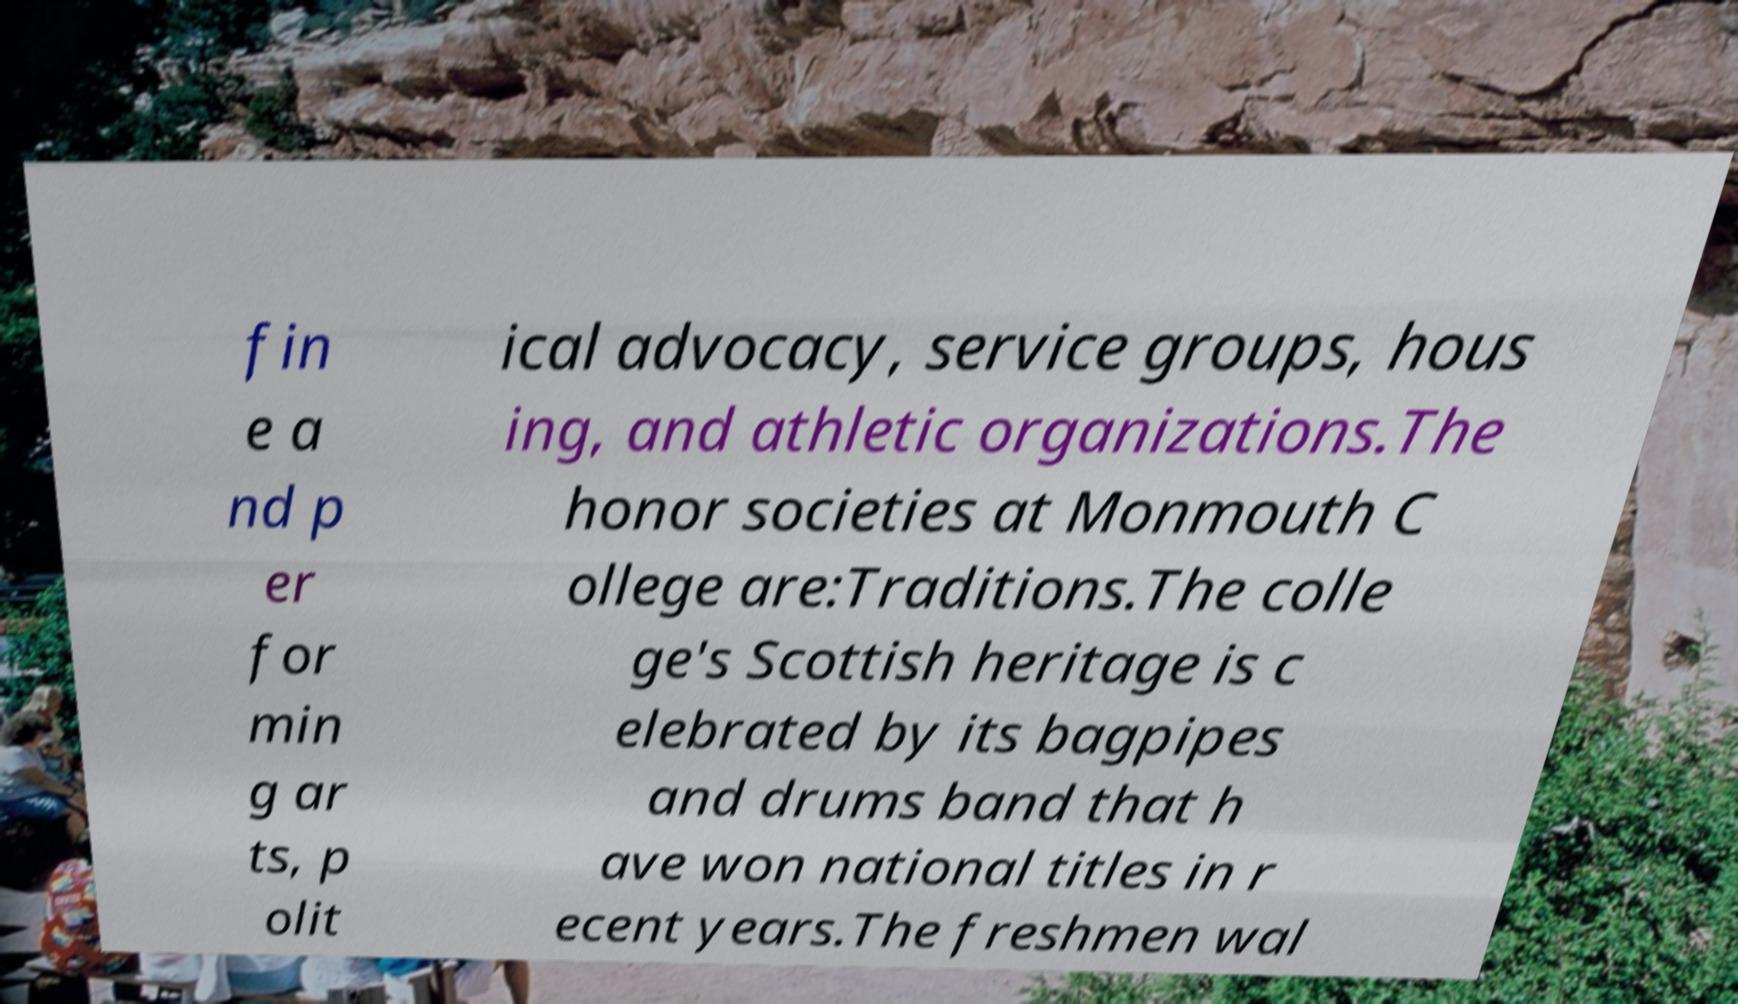Please read and relay the text visible in this image. What does it say? fin e a nd p er for min g ar ts, p olit ical advocacy, service groups, hous ing, and athletic organizations.The honor societies at Monmouth C ollege are:Traditions.The colle ge's Scottish heritage is c elebrated by its bagpipes and drums band that h ave won national titles in r ecent years.The freshmen wal 